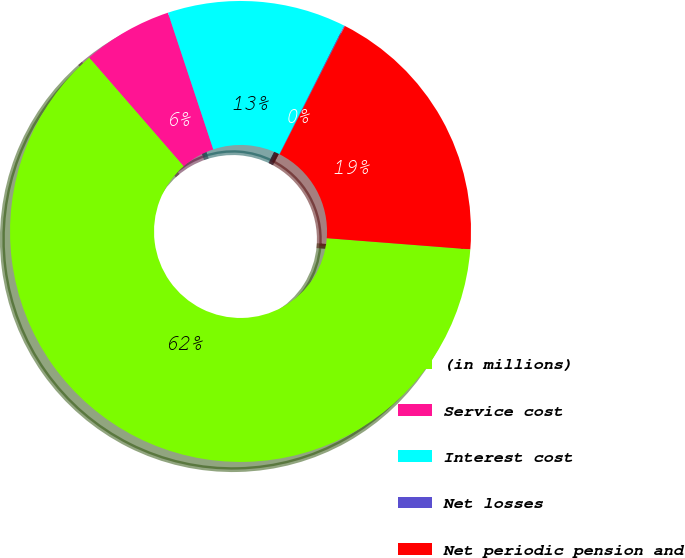Convert chart to OTSL. <chart><loc_0><loc_0><loc_500><loc_500><pie_chart><fcel>(in millions)<fcel>Service cost<fcel>Interest cost<fcel>Net losses<fcel>Net periodic pension and<nl><fcel>62.37%<fcel>6.29%<fcel>12.52%<fcel>0.06%<fcel>18.75%<nl></chart> 